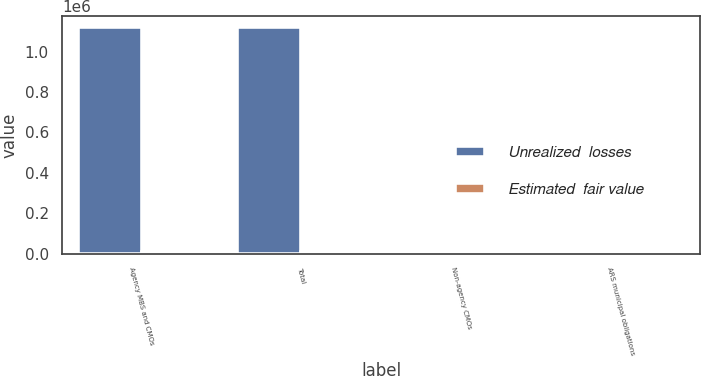Convert chart to OTSL. <chart><loc_0><loc_0><loc_500><loc_500><stacked_bar_chart><ecel><fcel>Agency MBS and CMOs<fcel>Total<fcel>Non-agency CMOs<fcel>ARS municipal obligations<nl><fcel>Unrealized  losses<fcel>1.11972e+06<fcel>1.11972e+06<fcel>4256<fcel>13204<nl><fcel>Estimated  fair value<fcel>5621<fcel>5621<fcel>21<fcel>697<nl></chart> 